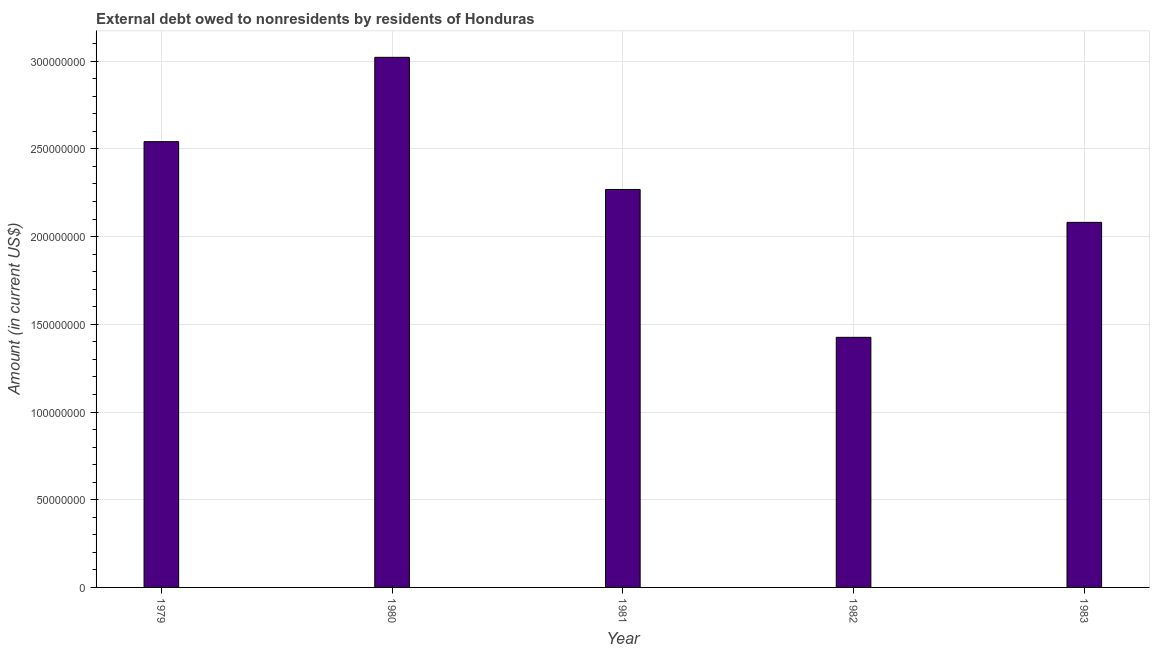Does the graph contain grids?
Ensure brevity in your answer.  Yes. What is the title of the graph?
Your answer should be very brief. External debt owed to nonresidents by residents of Honduras. What is the label or title of the Y-axis?
Provide a short and direct response. Amount (in current US$). What is the debt in 1982?
Make the answer very short. 1.43e+08. Across all years, what is the maximum debt?
Make the answer very short. 3.02e+08. Across all years, what is the minimum debt?
Offer a terse response. 1.43e+08. In which year was the debt minimum?
Give a very brief answer. 1982. What is the sum of the debt?
Ensure brevity in your answer.  1.13e+09. What is the difference between the debt in 1980 and 1982?
Keep it short and to the point. 1.60e+08. What is the average debt per year?
Offer a terse response. 2.27e+08. What is the median debt?
Ensure brevity in your answer.  2.27e+08. Do a majority of the years between 1979 and 1980 (inclusive) have debt greater than 80000000 US$?
Provide a short and direct response. Yes. What is the ratio of the debt in 1980 to that in 1981?
Offer a very short reply. 1.33. Is the debt in 1981 less than that in 1983?
Provide a short and direct response. No. What is the difference between the highest and the second highest debt?
Provide a short and direct response. 4.81e+07. What is the difference between the highest and the lowest debt?
Offer a terse response. 1.60e+08. In how many years, is the debt greater than the average debt taken over all years?
Provide a succinct answer. 3. How many years are there in the graph?
Make the answer very short. 5. What is the Amount (in current US$) of 1979?
Offer a very short reply. 2.54e+08. What is the Amount (in current US$) in 1980?
Your response must be concise. 3.02e+08. What is the Amount (in current US$) in 1981?
Your answer should be very brief. 2.27e+08. What is the Amount (in current US$) of 1982?
Make the answer very short. 1.43e+08. What is the Amount (in current US$) in 1983?
Provide a succinct answer. 2.08e+08. What is the difference between the Amount (in current US$) in 1979 and 1980?
Provide a short and direct response. -4.81e+07. What is the difference between the Amount (in current US$) in 1979 and 1981?
Keep it short and to the point. 2.73e+07. What is the difference between the Amount (in current US$) in 1979 and 1982?
Your answer should be very brief. 1.12e+08. What is the difference between the Amount (in current US$) in 1979 and 1983?
Your response must be concise. 4.60e+07. What is the difference between the Amount (in current US$) in 1980 and 1981?
Your response must be concise. 7.53e+07. What is the difference between the Amount (in current US$) in 1980 and 1982?
Make the answer very short. 1.60e+08. What is the difference between the Amount (in current US$) in 1980 and 1983?
Keep it short and to the point. 9.41e+07. What is the difference between the Amount (in current US$) in 1981 and 1982?
Give a very brief answer. 8.43e+07. What is the difference between the Amount (in current US$) in 1981 and 1983?
Offer a terse response. 1.88e+07. What is the difference between the Amount (in current US$) in 1982 and 1983?
Your answer should be very brief. -6.55e+07. What is the ratio of the Amount (in current US$) in 1979 to that in 1980?
Offer a terse response. 0.84. What is the ratio of the Amount (in current US$) in 1979 to that in 1981?
Offer a terse response. 1.12. What is the ratio of the Amount (in current US$) in 1979 to that in 1982?
Keep it short and to the point. 1.78. What is the ratio of the Amount (in current US$) in 1979 to that in 1983?
Your response must be concise. 1.22. What is the ratio of the Amount (in current US$) in 1980 to that in 1981?
Your answer should be very brief. 1.33. What is the ratio of the Amount (in current US$) in 1980 to that in 1982?
Give a very brief answer. 2.12. What is the ratio of the Amount (in current US$) in 1980 to that in 1983?
Your answer should be compact. 1.45. What is the ratio of the Amount (in current US$) in 1981 to that in 1982?
Offer a very short reply. 1.59. What is the ratio of the Amount (in current US$) in 1981 to that in 1983?
Provide a short and direct response. 1.09. What is the ratio of the Amount (in current US$) in 1982 to that in 1983?
Ensure brevity in your answer.  0.69. 